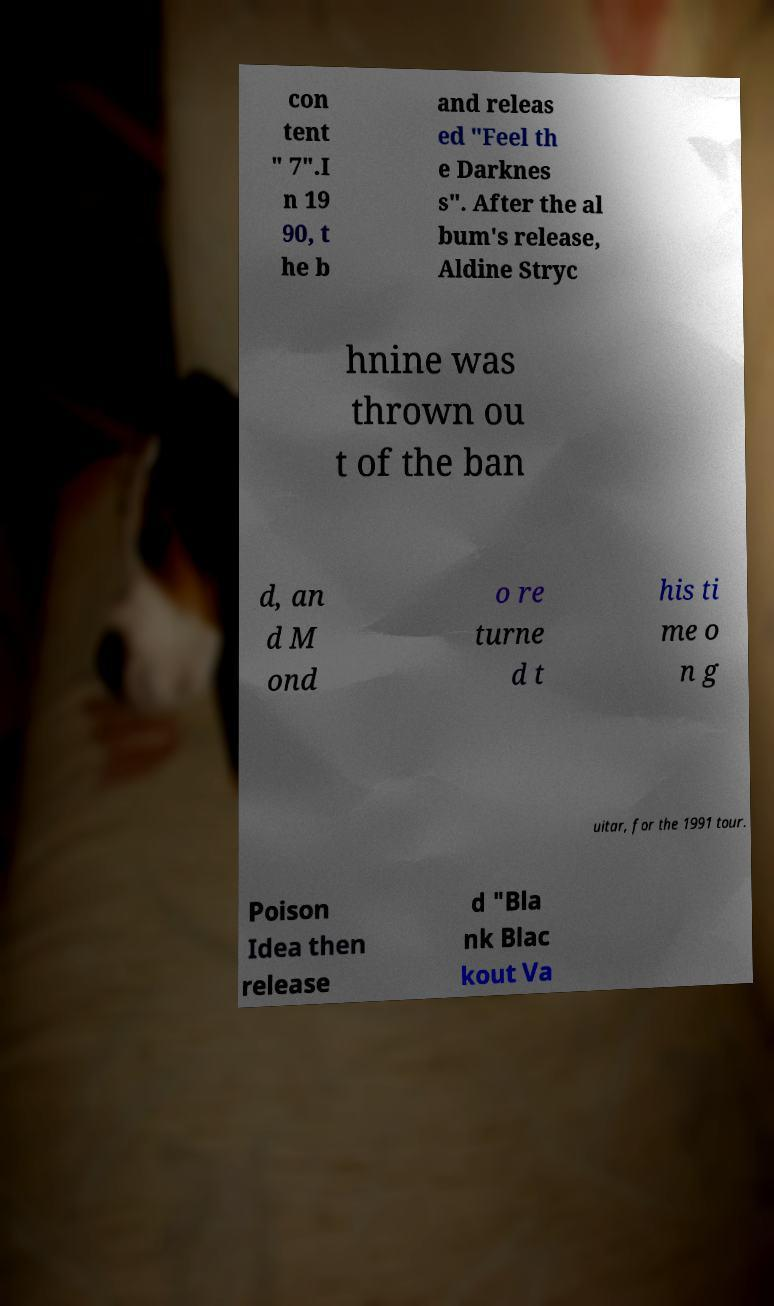Please read and relay the text visible in this image. What does it say? con tent " 7".I n 19 90, t he b and releas ed "Feel th e Darknes s". After the al bum's release, Aldine Stryc hnine was thrown ou t of the ban d, an d M ond o re turne d t his ti me o n g uitar, for the 1991 tour. Poison Idea then release d "Bla nk Blac kout Va 